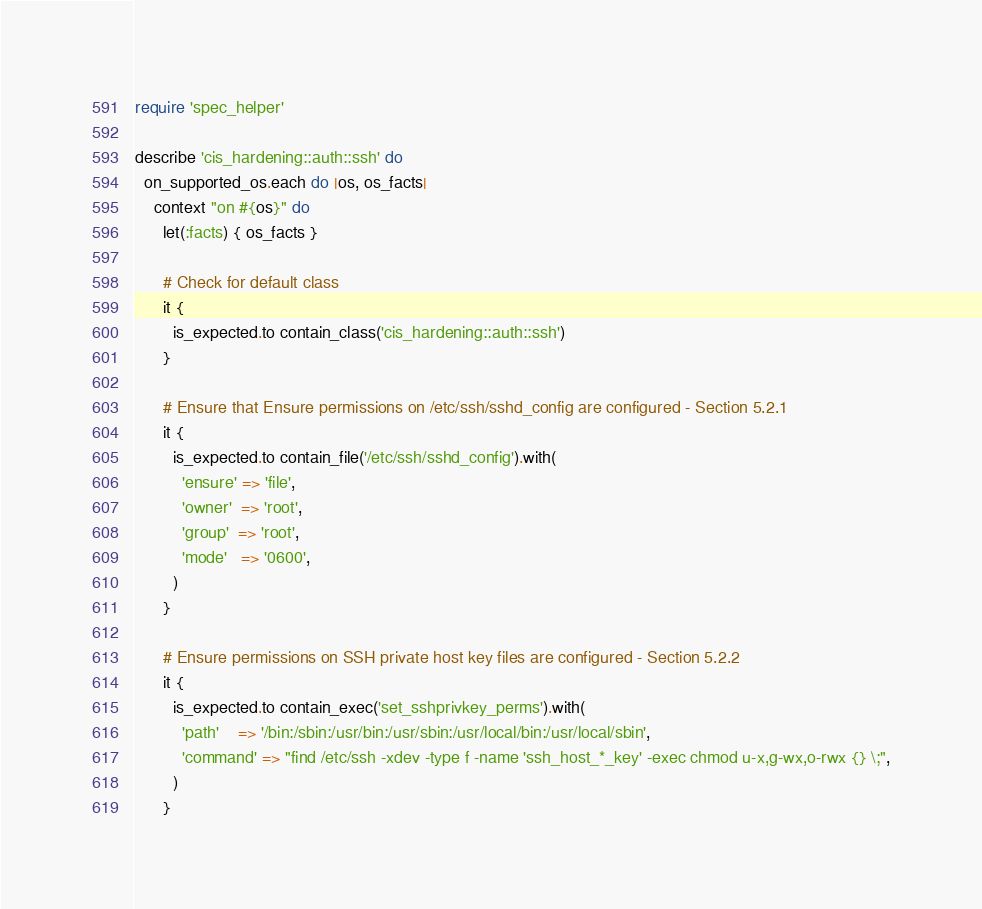<code> <loc_0><loc_0><loc_500><loc_500><_Ruby_>require 'spec_helper'

describe 'cis_hardening::auth::ssh' do
  on_supported_os.each do |os, os_facts|
    context "on #{os}" do
      let(:facts) { os_facts }

      # Check for default class
      it {
        is_expected.to contain_class('cis_hardening::auth::ssh')
      }

      # Ensure that Ensure permissions on /etc/ssh/sshd_config are configured - Section 5.2.1
      it {
        is_expected.to contain_file('/etc/ssh/sshd_config').with(
          'ensure' => 'file',
          'owner'  => 'root',
          'group'  => 'root',
          'mode'   => '0600',
        )
      }

      # Ensure permissions on SSH private host key files are configured - Section 5.2.2
      it {
        is_expected.to contain_exec('set_sshprivkey_perms').with(
          'path'    => '/bin:/sbin:/usr/bin:/usr/sbin:/usr/local/bin:/usr/local/sbin',
          'command' => "find /etc/ssh -xdev -type f -name 'ssh_host_*_key' -exec chmod u-x,g-wx,o-rwx {} \;",
        )
      }
</code> 